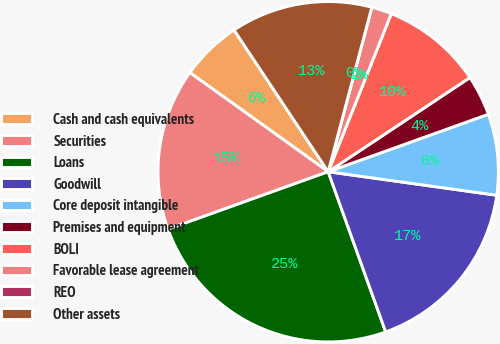Convert chart. <chart><loc_0><loc_0><loc_500><loc_500><pie_chart><fcel>Cash and cash equivalents<fcel>Securities<fcel>Loans<fcel>Goodwill<fcel>Core deposit intangible<fcel>Premises and equipment<fcel>BOLI<fcel>Favorable lease agreement<fcel>REO<fcel>Other assets<nl><fcel>5.77%<fcel>15.38%<fcel>25.0%<fcel>17.31%<fcel>7.69%<fcel>3.85%<fcel>9.62%<fcel>1.92%<fcel>0.0%<fcel>13.46%<nl></chart> 